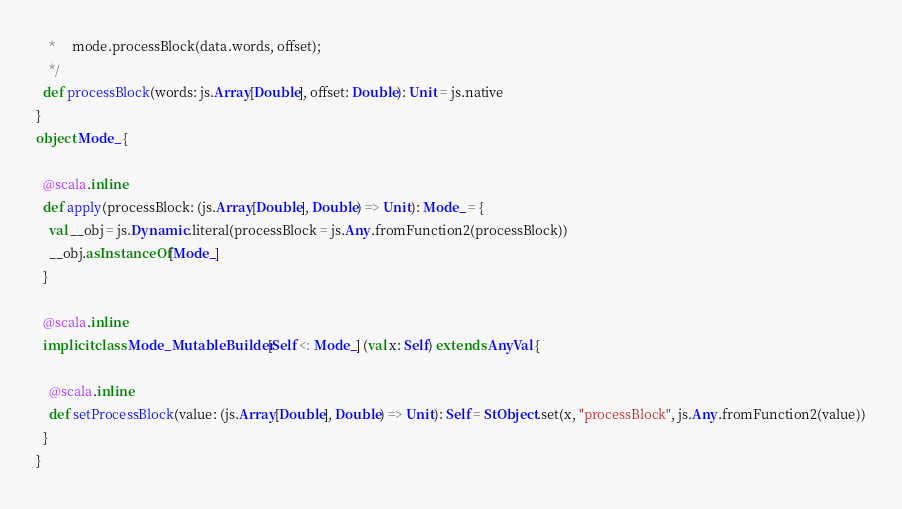<code> <loc_0><loc_0><loc_500><loc_500><_Scala_>    *     mode.processBlock(data.words, offset);
    */
  def processBlock(words: js.Array[Double], offset: Double): Unit = js.native
}
object Mode_ {
  
  @scala.inline
  def apply(processBlock: (js.Array[Double], Double) => Unit): Mode_ = {
    val __obj = js.Dynamic.literal(processBlock = js.Any.fromFunction2(processBlock))
    __obj.asInstanceOf[Mode_]
  }
  
  @scala.inline
  implicit class Mode_MutableBuilder[Self <: Mode_] (val x: Self) extends AnyVal {
    
    @scala.inline
    def setProcessBlock(value: (js.Array[Double], Double) => Unit): Self = StObject.set(x, "processBlock", js.Any.fromFunction2(value))
  }
}
</code> 